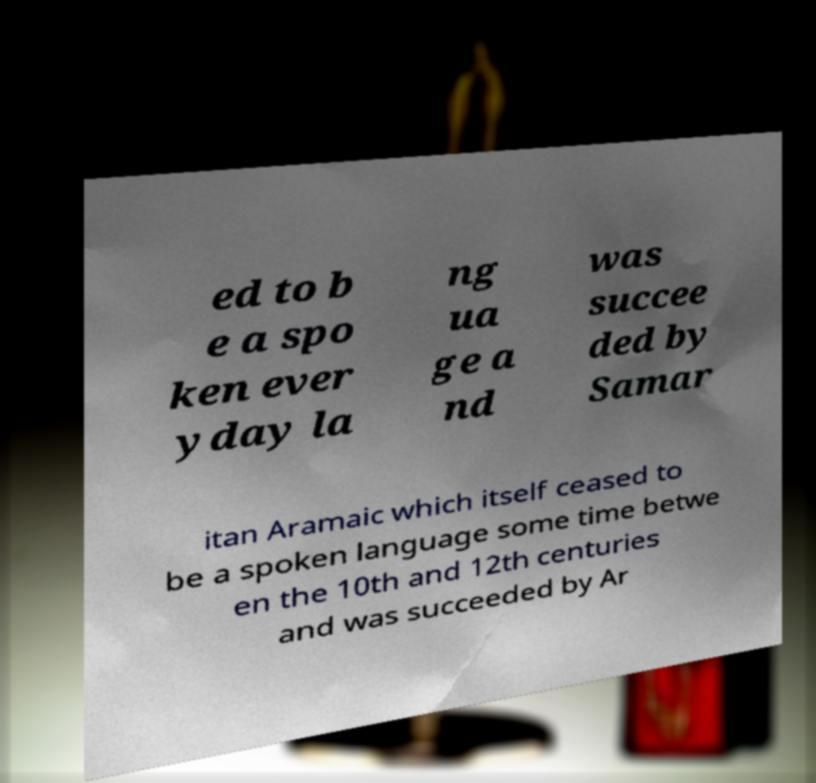Could you assist in decoding the text presented in this image and type it out clearly? ed to b e a spo ken ever yday la ng ua ge a nd was succee ded by Samar itan Aramaic which itself ceased to be a spoken language some time betwe en the 10th and 12th centuries and was succeeded by Ar 